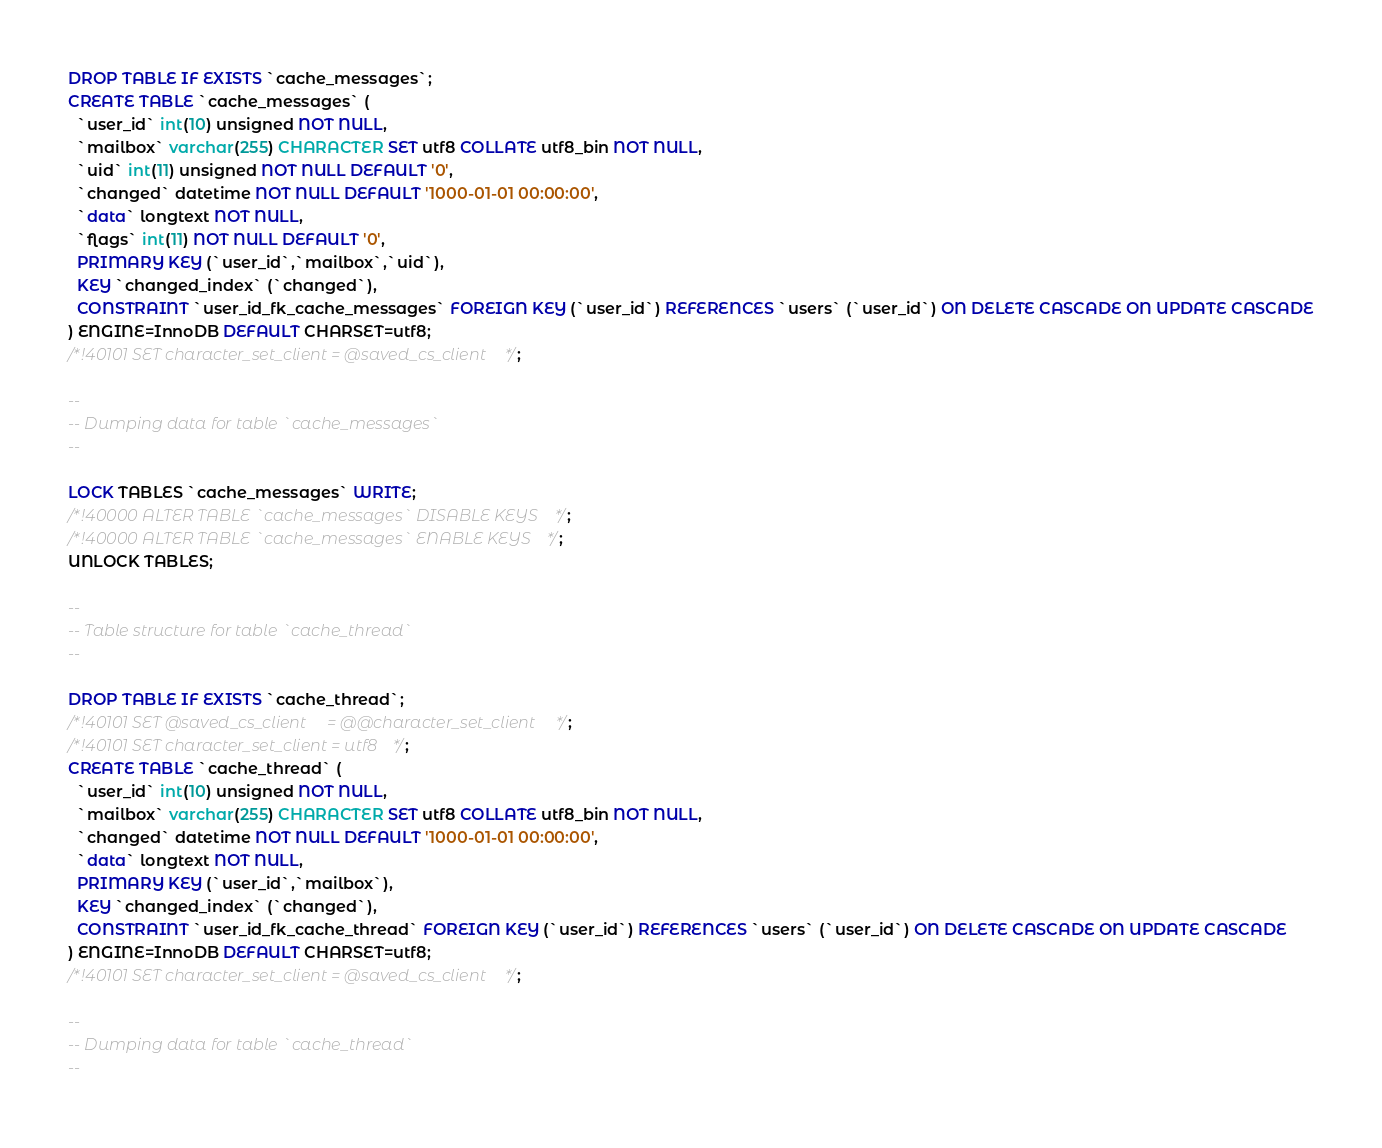<code> <loc_0><loc_0><loc_500><loc_500><_SQL_>DROP TABLE IF EXISTS `cache_messages`;
CREATE TABLE `cache_messages` (
  `user_id` int(10) unsigned NOT NULL,
  `mailbox` varchar(255) CHARACTER SET utf8 COLLATE utf8_bin NOT NULL,
  `uid` int(11) unsigned NOT NULL DEFAULT '0',
  `changed` datetime NOT NULL DEFAULT '1000-01-01 00:00:00',
  `data` longtext NOT NULL,
  `flags` int(11) NOT NULL DEFAULT '0',
  PRIMARY KEY (`user_id`,`mailbox`,`uid`),
  KEY `changed_index` (`changed`),
  CONSTRAINT `user_id_fk_cache_messages` FOREIGN KEY (`user_id`) REFERENCES `users` (`user_id`) ON DELETE CASCADE ON UPDATE CASCADE
) ENGINE=InnoDB DEFAULT CHARSET=utf8;
/*!40101 SET character_set_client = @saved_cs_client */;

--
-- Dumping data for table `cache_messages`
--

LOCK TABLES `cache_messages` WRITE;
/*!40000 ALTER TABLE `cache_messages` DISABLE KEYS */;
/*!40000 ALTER TABLE `cache_messages` ENABLE KEYS */;
UNLOCK TABLES;

--
-- Table structure for table `cache_thread`
--

DROP TABLE IF EXISTS `cache_thread`;
/*!40101 SET @saved_cs_client     = @@character_set_client */;
/*!40101 SET character_set_client = utf8 */;
CREATE TABLE `cache_thread` (
  `user_id` int(10) unsigned NOT NULL,
  `mailbox` varchar(255) CHARACTER SET utf8 COLLATE utf8_bin NOT NULL,
  `changed` datetime NOT NULL DEFAULT '1000-01-01 00:00:00',
  `data` longtext NOT NULL,
  PRIMARY KEY (`user_id`,`mailbox`),
  KEY `changed_index` (`changed`),
  CONSTRAINT `user_id_fk_cache_thread` FOREIGN KEY (`user_id`) REFERENCES `users` (`user_id`) ON DELETE CASCADE ON UPDATE CASCADE
) ENGINE=InnoDB DEFAULT CHARSET=utf8;
/*!40101 SET character_set_client = @saved_cs_client */;

--
-- Dumping data for table `cache_thread`
--
</code> 